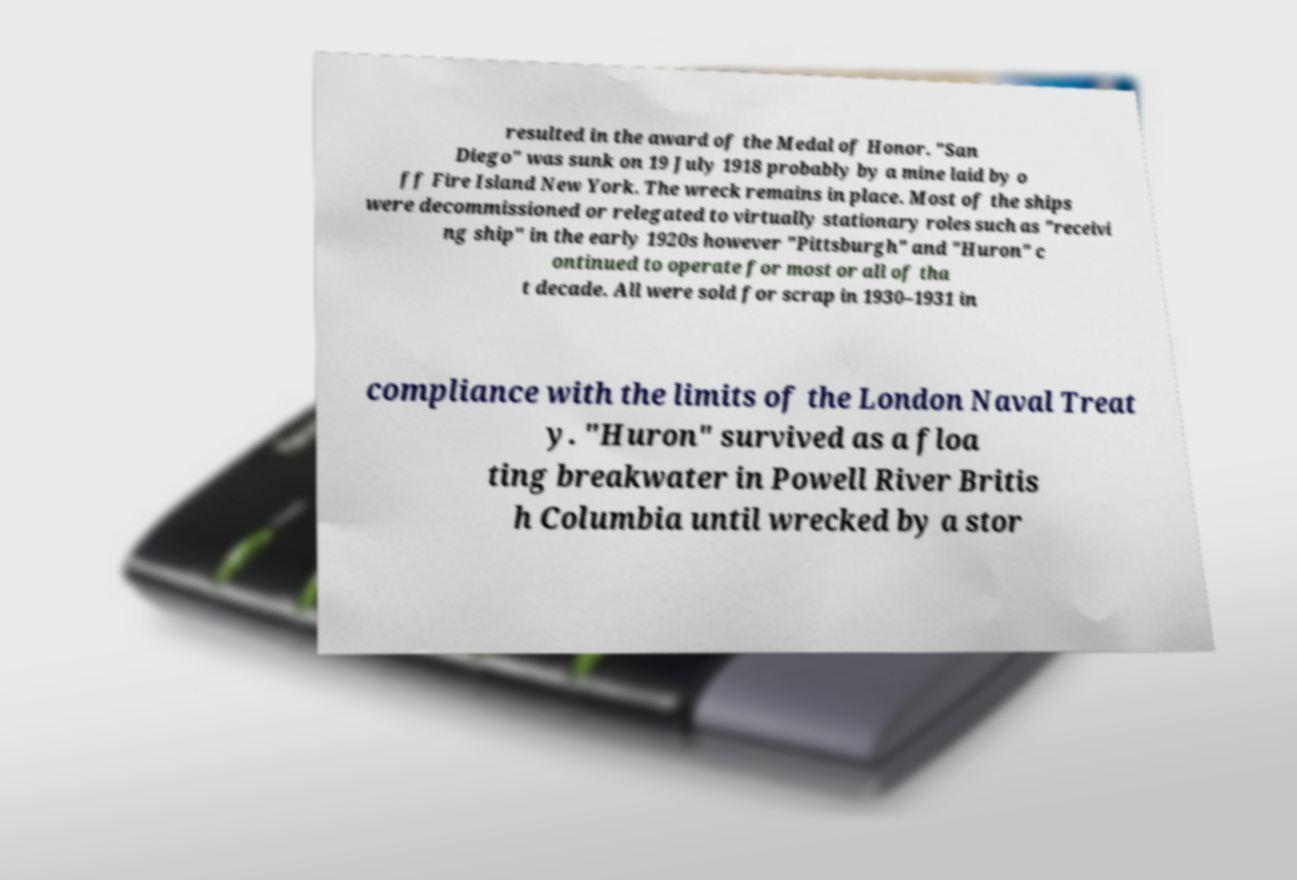Please identify and transcribe the text found in this image. resulted in the award of the Medal of Honor. "San Diego" was sunk on 19 July 1918 probably by a mine laid by o ff Fire Island New York. The wreck remains in place. Most of the ships were decommissioned or relegated to virtually stationary roles such as "receivi ng ship" in the early 1920s however "Pittsburgh" and "Huron" c ontinued to operate for most or all of tha t decade. All were sold for scrap in 1930–1931 in compliance with the limits of the London Naval Treat y. "Huron" survived as a floa ting breakwater in Powell River Britis h Columbia until wrecked by a stor 